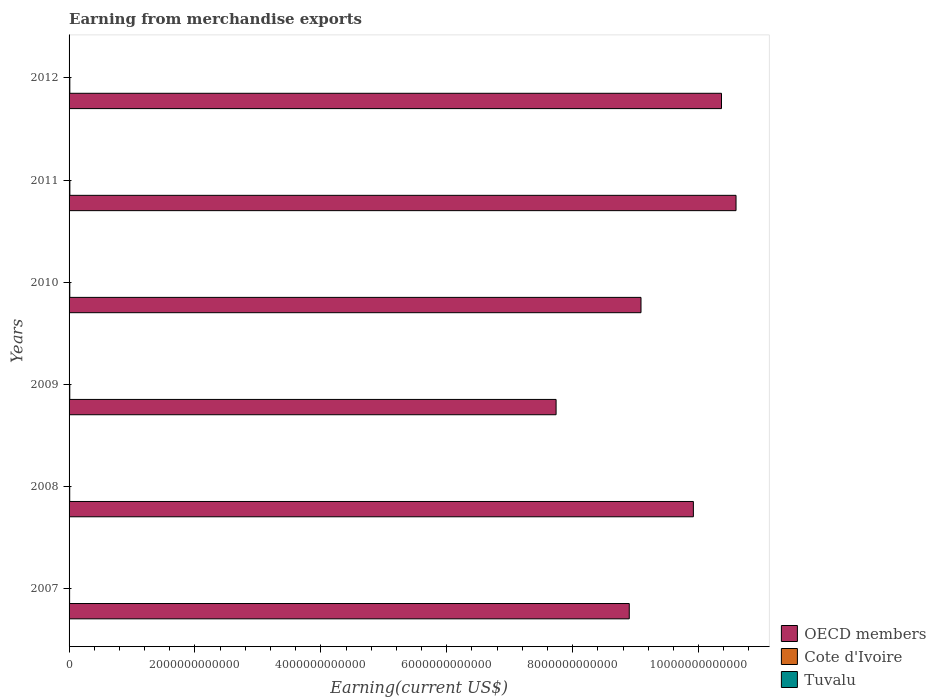Are the number of bars per tick equal to the number of legend labels?
Offer a very short reply. Yes. How many bars are there on the 5th tick from the top?
Offer a terse response. 3. What is the label of the 5th group of bars from the top?
Your answer should be very brief. 2008. In how many cases, is the number of bars for a given year not equal to the number of legend labels?
Provide a short and direct response. 0. Across all years, what is the maximum amount earned from merchandise exports in OECD members?
Keep it short and to the point. 1.06e+13. Across all years, what is the minimum amount earned from merchandise exports in Cote d'Ivoire?
Your answer should be very brief. 8.67e+09. In which year was the amount earned from merchandise exports in Cote d'Ivoire minimum?
Your answer should be compact. 2007. What is the total amount earned from merchandise exports in Tuvalu in the graph?
Ensure brevity in your answer.  1.49e+06. What is the difference between the amount earned from merchandise exports in OECD members in 2008 and that in 2009?
Provide a short and direct response. 2.18e+12. What is the difference between the amount earned from merchandise exports in Cote d'Ivoire in 2007 and the amount earned from merchandise exports in OECD members in 2012?
Offer a very short reply. -1.04e+13. What is the average amount earned from merchandise exports in OECD members per year?
Give a very brief answer. 9.43e+12. In the year 2009, what is the difference between the amount earned from merchandise exports in OECD members and amount earned from merchandise exports in Tuvalu?
Make the answer very short. 7.74e+12. In how many years, is the amount earned from merchandise exports in Tuvalu greater than 3600000000000 US$?
Ensure brevity in your answer.  0. What is the ratio of the amount earned from merchandise exports in OECD members in 2008 to that in 2009?
Your answer should be compact. 1.28. Is the amount earned from merchandise exports in Cote d'Ivoire in 2009 less than that in 2011?
Offer a terse response. Yes. Is the difference between the amount earned from merchandise exports in OECD members in 2008 and 2012 greater than the difference between the amount earned from merchandise exports in Tuvalu in 2008 and 2012?
Offer a very short reply. No. What is the difference between the highest and the second highest amount earned from merchandise exports in Cote d'Ivoire?
Your answer should be compact. 5.11e+08. What is the difference between the highest and the lowest amount earned from merchandise exports in OECD members?
Offer a very short reply. 2.86e+12. In how many years, is the amount earned from merchandise exports in Cote d'Ivoire greater than the average amount earned from merchandise exports in Cote d'Ivoire taken over all years?
Offer a very short reply. 4. Is the sum of the amount earned from merchandise exports in Cote d'Ivoire in 2008 and 2010 greater than the maximum amount earned from merchandise exports in Tuvalu across all years?
Your response must be concise. Yes. What does the 1st bar from the top in 2007 represents?
Offer a very short reply. Tuvalu. What does the 3rd bar from the bottom in 2012 represents?
Offer a very short reply. Tuvalu. How many bars are there?
Provide a succinct answer. 18. How many years are there in the graph?
Keep it short and to the point. 6. What is the difference between two consecutive major ticks on the X-axis?
Your answer should be very brief. 2.00e+12. Are the values on the major ticks of X-axis written in scientific E-notation?
Provide a succinct answer. No. Does the graph contain any zero values?
Ensure brevity in your answer.  No. Where does the legend appear in the graph?
Keep it short and to the point. Bottom right. What is the title of the graph?
Offer a terse response. Earning from merchandise exports. Does "Slovenia" appear as one of the legend labels in the graph?
Offer a very short reply. No. What is the label or title of the X-axis?
Offer a terse response. Earning(current US$). What is the Earning(current US$) of OECD members in 2007?
Your response must be concise. 8.90e+12. What is the Earning(current US$) in Cote d'Ivoire in 2007?
Your response must be concise. 8.67e+09. What is the Earning(current US$) in Tuvalu in 2007?
Your response must be concise. 9.20e+04. What is the Earning(current US$) of OECD members in 2008?
Make the answer very short. 9.92e+12. What is the Earning(current US$) of Cote d'Ivoire in 2008?
Keep it short and to the point. 1.04e+1. What is the Earning(current US$) of Tuvalu in 2008?
Ensure brevity in your answer.  2.00e+05. What is the Earning(current US$) of OECD members in 2009?
Offer a very short reply. 7.74e+12. What is the Earning(current US$) in Cote d'Ivoire in 2009?
Offer a very short reply. 1.13e+1. What is the Earning(current US$) of Tuvalu in 2009?
Provide a short and direct response. 3.00e+05. What is the Earning(current US$) in OECD members in 2010?
Offer a very short reply. 9.09e+12. What is the Earning(current US$) in Cote d'Ivoire in 2010?
Keep it short and to the point. 1.14e+1. What is the Earning(current US$) of OECD members in 2011?
Keep it short and to the point. 1.06e+13. What is the Earning(current US$) of Cote d'Ivoire in 2011?
Your answer should be very brief. 1.26e+1. What is the Earning(current US$) of Tuvalu in 2011?
Provide a short and direct response. 3.00e+05. What is the Earning(current US$) of OECD members in 2012?
Provide a short and direct response. 1.04e+13. What is the Earning(current US$) of Cote d'Ivoire in 2012?
Make the answer very short. 1.21e+1. Across all years, what is the maximum Earning(current US$) in OECD members?
Provide a short and direct response. 1.06e+13. Across all years, what is the maximum Earning(current US$) in Cote d'Ivoire?
Your answer should be compact. 1.26e+1. Across all years, what is the maximum Earning(current US$) of Tuvalu?
Your answer should be compact. 3.00e+05. Across all years, what is the minimum Earning(current US$) in OECD members?
Your answer should be very brief. 7.74e+12. Across all years, what is the minimum Earning(current US$) of Cote d'Ivoire?
Offer a terse response. 8.67e+09. Across all years, what is the minimum Earning(current US$) in Tuvalu?
Your answer should be very brief. 9.20e+04. What is the total Earning(current US$) in OECD members in the graph?
Offer a terse response. 5.66e+13. What is the total Earning(current US$) of Cote d'Ivoire in the graph?
Offer a terse response. 6.66e+1. What is the total Earning(current US$) of Tuvalu in the graph?
Your answer should be very brief. 1.49e+06. What is the difference between the Earning(current US$) of OECD members in 2007 and that in 2008?
Provide a succinct answer. -1.02e+12. What is the difference between the Earning(current US$) of Cote d'Ivoire in 2007 and that in 2008?
Provide a succinct answer. -1.72e+09. What is the difference between the Earning(current US$) in Tuvalu in 2007 and that in 2008?
Offer a very short reply. -1.08e+05. What is the difference between the Earning(current US$) in OECD members in 2007 and that in 2009?
Ensure brevity in your answer.  1.16e+12. What is the difference between the Earning(current US$) in Cote d'Ivoire in 2007 and that in 2009?
Offer a very short reply. -2.66e+09. What is the difference between the Earning(current US$) of Tuvalu in 2007 and that in 2009?
Your answer should be very brief. -2.08e+05. What is the difference between the Earning(current US$) of OECD members in 2007 and that in 2010?
Your response must be concise. -1.87e+11. What is the difference between the Earning(current US$) of Cote d'Ivoire in 2007 and that in 2010?
Ensure brevity in your answer.  -2.74e+09. What is the difference between the Earning(current US$) of Tuvalu in 2007 and that in 2010?
Offer a very short reply. -2.08e+05. What is the difference between the Earning(current US$) of OECD members in 2007 and that in 2011?
Provide a succinct answer. -1.70e+12. What is the difference between the Earning(current US$) of Cote d'Ivoire in 2007 and that in 2011?
Your answer should be compact. -3.97e+09. What is the difference between the Earning(current US$) in Tuvalu in 2007 and that in 2011?
Give a very brief answer. -2.08e+05. What is the difference between the Earning(current US$) in OECD members in 2007 and that in 2012?
Your answer should be compact. -1.47e+12. What is the difference between the Earning(current US$) in Cote d'Ivoire in 2007 and that in 2012?
Provide a succinct answer. -3.46e+09. What is the difference between the Earning(current US$) of Tuvalu in 2007 and that in 2012?
Give a very brief answer. -2.08e+05. What is the difference between the Earning(current US$) of OECD members in 2008 and that in 2009?
Your answer should be compact. 2.18e+12. What is the difference between the Earning(current US$) of Cote d'Ivoire in 2008 and that in 2009?
Your answer should be very brief. -9.37e+08. What is the difference between the Earning(current US$) of OECD members in 2008 and that in 2010?
Offer a very short reply. 8.32e+11. What is the difference between the Earning(current US$) in Cote d'Ivoire in 2008 and that in 2010?
Provide a succinct answer. -1.02e+09. What is the difference between the Earning(current US$) of OECD members in 2008 and that in 2011?
Offer a terse response. -6.78e+11. What is the difference between the Earning(current US$) of Cote d'Ivoire in 2008 and that in 2011?
Your response must be concise. -2.25e+09. What is the difference between the Earning(current US$) of Tuvalu in 2008 and that in 2011?
Offer a terse response. -1.00e+05. What is the difference between the Earning(current US$) of OECD members in 2008 and that in 2012?
Your answer should be very brief. -4.47e+11. What is the difference between the Earning(current US$) of Cote d'Ivoire in 2008 and that in 2012?
Provide a succinct answer. -1.73e+09. What is the difference between the Earning(current US$) of OECD members in 2009 and that in 2010?
Make the answer very short. -1.35e+12. What is the difference between the Earning(current US$) of Cote d'Ivoire in 2009 and that in 2010?
Keep it short and to the point. -8.33e+07. What is the difference between the Earning(current US$) of OECD members in 2009 and that in 2011?
Provide a short and direct response. -2.86e+12. What is the difference between the Earning(current US$) of Cote d'Ivoire in 2009 and that in 2011?
Offer a very short reply. -1.31e+09. What is the difference between the Earning(current US$) of OECD members in 2009 and that in 2012?
Keep it short and to the point. -2.63e+12. What is the difference between the Earning(current US$) of Cote d'Ivoire in 2009 and that in 2012?
Give a very brief answer. -7.97e+08. What is the difference between the Earning(current US$) in OECD members in 2010 and that in 2011?
Provide a short and direct response. -1.51e+12. What is the difference between the Earning(current US$) in Cote d'Ivoire in 2010 and that in 2011?
Make the answer very short. -1.22e+09. What is the difference between the Earning(current US$) in OECD members in 2010 and that in 2012?
Offer a terse response. -1.28e+12. What is the difference between the Earning(current US$) of Cote d'Ivoire in 2010 and that in 2012?
Offer a very short reply. -7.14e+08. What is the difference between the Earning(current US$) in OECD members in 2011 and that in 2012?
Ensure brevity in your answer.  2.31e+11. What is the difference between the Earning(current US$) in Cote d'Ivoire in 2011 and that in 2012?
Provide a succinct answer. 5.11e+08. What is the difference between the Earning(current US$) in Tuvalu in 2011 and that in 2012?
Give a very brief answer. 0. What is the difference between the Earning(current US$) of OECD members in 2007 and the Earning(current US$) of Cote d'Ivoire in 2008?
Provide a succinct answer. 8.89e+12. What is the difference between the Earning(current US$) in OECD members in 2007 and the Earning(current US$) in Tuvalu in 2008?
Your answer should be very brief. 8.90e+12. What is the difference between the Earning(current US$) in Cote d'Ivoire in 2007 and the Earning(current US$) in Tuvalu in 2008?
Your answer should be very brief. 8.67e+09. What is the difference between the Earning(current US$) of OECD members in 2007 and the Earning(current US$) of Cote d'Ivoire in 2009?
Provide a short and direct response. 8.89e+12. What is the difference between the Earning(current US$) in OECD members in 2007 and the Earning(current US$) in Tuvalu in 2009?
Keep it short and to the point. 8.90e+12. What is the difference between the Earning(current US$) in Cote d'Ivoire in 2007 and the Earning(current US$) in Tuvalu in 2009?
Offer a terse response. 8.67e+09. What is the difference between the Earning(current US$) of OECD members in 2007 and the Earning(current US$) of Cote d'Ivoire in 2010?
Keep it short and to the point. 8.89e+12. What is the difference between the Earning(current US$) of OECD members in 2007 and the Earning(current US$) of Tuvalu in 2010?
Your answer should be very brief. 8.90e+12. What is the difference between the Earning(current US$) of Cote d'Ivoire in 2007 and the Earning(current US$) of Tuvalu in 2010?
Provide a succinct answer. 8.67e+09. What is the difference between the Earning(current US$) in OECD members in 2007 and the Earning(current US$) in Cote d'Ivoire in 2011?
Give a very brief answer. 8.89e+12. What is the difference between the Earning(current US$) of OECD members in 2007 and the Earning(current US$) of Tuvalu in 2011?
Your answer should be very brief. 8.90e+12. What is the difference between the Earning(current US$) of Cote d'Ivoire in 2007 and the Earning(current US$) of Tuvalu in 2011?
Keep it short and to the point. 8.67e+09. What is the difference between the Earning(current US$) of OECD members in 2007 and the Earning(current US$) of Cote d'Ivoire in 2012?
Ensure brevity in your answer.  8.89e+12. What is the difference between the Earning(current US$) in OECD members in 2007 and the Earning(current US$) in Tuvalu in 2012?
Make the answer very short. 8.90e+12. What is the difference between the Earning(current US$) in Cote d'Ivoire in 2007 and the Earning(current US$) in Tuvalu in 2012?
Give a very brief answer. 8.67e+09. What is the difference between the Earning(current US$) in OECD members in 2008 and the Earning(current US$) in Cote d'Ivoire in 2009?
Your answer should be very brief. 9.91e+12. What is the difference between the Earning(current US$) in OECD members in 2008 and the Earning(current US$) in Tuvalu in 2009?
Make the answer very short. 9.92e+12. What is the difference between the Earning(current US$) of Cote d'Ivoire in 2008 and the Earning(current US$) of Tuvalu in 2009?
Your response must be concise. 1.04e+1. What is the difference between the Earning(current US$) in OECD members in 2008 and the Earning(current US$) in Cote d'Ivoire in 2010?
Provide a succinct answer. 9.91e+12. What is the difference between the Earning(current US$) in OECD members in 2008 and the Earning(current US$) in Tuvalu in 2010?
Provide a short and direct response. 9.92e+12. What is the difference between the Earning(current US$) of Cote d'Ivoire in 2008 and the Earning(current US$) of Tuvalu in 2010?
Ensure brevity in your answer.  1.04e+1. What is the difference between the Earning(current US$) in OECD members in 2008 and the Earning(current US$) in Cote d'Ivoire in 2011?
Offer a very short reply. 9.90e+12. What is the difference between the Earning(current US$) in OECD members in 2008 and the Earning(current US$) in Tuvalu in 2011?
Keep it short and to the point. 9.92e+12. What is the difference between the Earning(current US$) of Cote d'Ivoire in 2008 and the Earning(current US$) of Tuvalu in 2011?
Ensure brevity in your answer.  1.04e+1. What is the difference between the Earning(current US$) of OECD members in 2008 and the Earning(current US$) of Cote d'Ivoire in 2012?
Provide a succinct answer. 9.91e+12. What is the difference between the Earning(current US$) in OECD members in 2008 and the Earning(current US$) in Tuvalu in 2012?
Provide a succinct answer. 9.92e+12. What is the difference between the Earning(current US$) of Cote d'Ivoire in 2008 and the Earning(current US$) of Tuvalu in 2012?
Give a very brief answer. 1.04e+1. What is the difference between the Earning(current US$) in OECD members in 2009 and the Earning(current US$) in Cote d'Ivoire in 2010?
Offer a very short reply. 7.73e+12. What is the difference between the Earning(current US$) in OECD members in 2009 and the Earning(current US$) in Tuvalu in 2010?
Offer a terse response. 7.74e+12. What is the difference between the Earning(current US$) in Cote d'Ivoire in 2009 and the Earning(current US$) in Tuvalu in 2010?
Keep it short and to the point. 1.13e+1. What is the difference between the Earning(current US$) in OECD members in 2009 and the Earning(current US$) in Cote d'Ivoire in 2011?
Your answer should be very brief. 7.72e+12. What is the difference between the Earning(current US$) in OECD members in 2009 and the Earning(current US$) in Tuvalu in 2011?
Offer a terse response. 7.74e+12. What is the difference between the Earning(current US$) of Cote d'Ivoire in 2009 and the Earning(current US$) of Tuvalu in 2011?
Your answer should be very brief. 1.13e+1. What is the difference between the Earning(current US$) in OECD members in 2009 and the Earning(current US$) in Cote d'Ivoire in 2012?
Offer a very short reply. 7.72e+12. What is the difference between the Earning(current US$) in OECD members in 2009 and the Earning(current US$) in Tuvalu in 2012?
Your answer should be very brief. 7.74e+12. What is the difference between the Earning(current US$) of Cote d'Ivoire in 2009 and the Earning(current US$) of Tuvalu in 2012?
Make the answer very short. 1.13e+1. What is the difference between the Earning(current US$) in OECD members in 2010 and the Earning(current US$) in Cote d'Ivoire in 2011?
Your response must be concise. 9.07e+12. What is the difference between the Earning(current US$) in OECD members in 2010 and the Earning(current US$) in Tuvalu in 2011?
Ensure brevity in your answer.  9.09e+12. What is the difference between the Earning(current US$) in Cote d'Ivoire in 2010 and the Earning(current US$) in Tuvalu in 2011?
Offer a terse response. 1.14e+1. What is the difference between the Earning(current US$) of OECD members in 2010 and the Earning(current US$) of Cote d'Ivoire in 2012?
Provide a succinct answer. 9.07e+12. What is the difference between the Earning(current US$) of OECD members in 2010 and the Earning(current US$) of Tuvalu in 2012?
Your response must be concise. 9.09e+12. What is the difference between the Earning(current US$) of Cote d'Ivoire in 2010 and the Earning(current US$) of Tuvalu in 2012?
Your answer should be very brief. 1.14e+1. What is the difference between the Earning(current US$) of OECD members in 2011 and the Earning(current US$) of Cote d'Ivoire in 2012?
Your response must be concise. 1.06e+13. What is the difference between the Earning(current US$) in OECD members in 2011 and the Earning(current US$) in Tuvalu in 2012?
Give a very brief answer. 1.06e+13. What is the difference between the Earning(current US$) in Cote d'Ivoire in 2011 and the Earning(current US$) in Tuvalu in 2012?
Your response must be concise. 1.26e+1. What is the average Earning(current US$) of OECD members per year?
Ensure brevity in your answer.  9.43e+12. What is the average Earning(current US$) of Cote d'Ivoire per year?
Offer a very short reply. 1.11e+1. What is the average Earning(current US$) in Tuvalu per year?
Keep it short and to the point. 2.49e+05. In the year 2007, what is the difference between the Earning(current US$) of OECD members and Earning(current US$) of Cote d'Ivoire?
Make the answer very short. 8.89e+12. In the year 2007, what is the difference between the Earning(current US$) of OECD members and Earning(current US$) of Tuvalu?
Make the answer very short. 8.90e+12. In the year 2007, what is the difference between the Earning(current US$) in Cote d'Ivoire and Earning(current US$) in Tuvalu?
Ensure brevity in your answer.  8.67e+09. In the year 2008, what is the difference between the Earning(current US$) in OECD members and Earning(current US$) in Cote d'Ivoire?
Your answer should be compact. 9.91e+12. In the year 2008, what is the difference between the Earning(current US$) in OECD members and Earning(current US$) in Tuvalu?
Make the answer very short. 9.92e+12. In the year 2008, what is the difference between the Earning(current US$) of Cote d'Ivoire and Earning(current US$) of Tuvalu?
Your answer should be very brief. 1.04e+1. In the year 2009, what is the difference between the Earning(current US$) in OECD members and Earning(current US$) in Cote d'Ivoire?
Provide a succinct answer. 7.73e+12. In the year 2009, what is the difference between the Earning(current US$) in OECD members and Earning(current US$) in Tuvalu?
Provide a short and direct response. 7.74e+12. In the year 2009, what is the difference between the Earning(current US$) in Cote d'Ivoire and Earning(current US$) in Tuvalu?
Provide a succinct answer. 1.13e+1. In the year 2010, what is the difference between the Earning(current US$) of OECD members and Earning(current US$) of Cote d'Ivoire?
Make the answer very short. 9.07e+12. In the year 2010, what is the difference between the Earning(current US$) in OECD members and Earning(current US$) in Tuvalu?
Give a very brief answer. 9.09e+12. In the year 2010, what is the difference between the Earning(current US$) of Cote d'Ivoire and Earning(current US$) of Tuvalu?
Provide a succinct answer. 1.14e+1. In the year 2011, what is the difference between the Earning(current US$) in OECD members and Earning(current US$) in Cote d'Ivoire?
Make the answer very short. 1.06e+13. In the year 2011, what is the difference between the Earning(current US$) of OECD members and Earning(current US$) of Tuvalu?
Keep it short and to the point. 1.06e+13. In the year 2011, what is the difference between the Earning(current US$) in Cote d'Ivoire and Earning(current US$) in Tuvalu?
Give a very brief answer. 1.26e+1. In the year 2012, what is the difference between the Earning(current US$) in OECD members and Earning(current US$) in Cote d'Ivoire?
Offer a very short reply. 1.04e+13. In the year 2012, what is the difference between the Earning(current US$) in OECD members and Earning(current US$) in Tuvalu?
Provide a succinct answer. 1.04e+13. In the year 2012, what is the difference between the Earning(current US$) in Cote d'Ivoire and Earning(current US$) in Tuvalu?
Offer a very short reply. 1.21e+1. What is the ratio of the Earning(current US$) in OECD members in 2007 to that in 2008?
Make the answer very short. 0.9. What is the ratio of the Earning(current US$) in Cote d'Ivoire in 2007 to that in 2008?
Ensure brevity in your answer.  0.83. What is the ratio of the Earning(current US$) in Tuvalu in 2007 to that in 2008?
Your answer should be compact. 0.46. What is the ratio of the Earning(current US$) in OECD members in 2007 to that in 2009?
Your answer should be compact. 1.15. What is the ratio of the Earning(current US$) in Cote d'Ivoire in 2007 to that in 2009?
Make the answer very short. 0.77. What is the ratio of the Earning(current US$) of Tuvalu in 2007 to that in 2009?
Your response must be concise. 0.31. What is the ratio of the Earning(current US$) in OECD members in 2007 to that in 2010?
Make the answer very short. 0.98. What is the ratio of the Earning(current US$) in Cote d'Ivoire in 2007 to that in 2010?
Ensure brevity in your answer.  0.76. What is the ratio of the Earning(current US$) of Tuvalu in 2007 to that in 2010?
Provide a short and direct response. 0.31. What is the ratio of the Earning(current US$) of OECD members in 2007 to that in 2011?
Make the answer very short. 0.84. What is the ratio of the Earning(current US$) of Cote d'Ivoire in 2007 to that in 2011?
Make the answer very short. 0.69. What is the ratio of the Earning(current US$) in Tuvalu in 2007 to that in 2011?
Give a very brief answer. 0.31. What is the ratio of the Earning(current US$) of OECD members in 2007 to that in 2012?
Offer a terse response. 0.86. What is the ratio of the Earning(current US$) in Cote d'Ivoire in 2007 to that in 2012?
Offer a very short reply. 0.71. What is the ratio of the Earning(current US$) of Tuvalu in 2007 to that in 2012?
Provide a succinct answer. 0.31. What is the ratio of the Earning(current US$) in OECD members in 2008 to that in 2009?
Your answer should be very brief. 1.28. What is the ratio of the Earning(current US$) of Cote d'Ivoire in 2008 to that in 2009?
Provide a succinct answer. 0.92. What is the ratio of the Earning(current US$) of OECD members in 2008 to that in 2010?
Make the answer very short. 1.09. What is the ratio of the Earning(current US$) in Cote d'Ivoire in 2008 to that in 2010?
Your answer should be very brief. 0.91. What is the ratio of the Earning(current US$) in Tuvalu in 2008 to that in 2010?
Give a very brief answer. 0.67. What is the ratio of the Earning(current US$) in OECD members in 2008 to that in 2011?
Your answer should be compact. 0.94. What is the ratio of the Earning(current US$) of Cote d'Ivoire in 2008 to that in 2011?
Keep it short and to the point. 0.82. What is the ratio of the Earning(current US$) in OECD members in 2008 to that in 2012?
Offer a very short reply. 0.96. What is the ratio of the Earning(current US$) of Cote d'Ivoire in 2008 to that in 2012?
Provide a succinct answer. 0.86. What is the ratio of the Earning(current US$) of OECD members in 2009 to that in 2010?
Your response must be concise. 0.85. What is the ratio of the Earning(current US$) in Tuvalu in 2009 to that in 2010?
Provide a succinct answer. 1. What is the ratio of the Earning(current US$) of OECD members in 2009 to that in 2011?
Provide a succinct answer. 0.73. What is the ratio of the Earning(current US$) of Cote d'Ivoire in 2009 to that in 2011?
Your answer should be compact. 0.9. What is the ratio of the Earning(current US$) in OECD members in 2009 to that in 2012?
Keep it short and to the point. 0.75. What is the ratio of the Earning(current US$) of Cote d'Ivoire in 2009 to that in 2012?
Give a very brief answer. 0.93. What is the ratio of the Earning(current US$) of Tuvalu in 2009 to that in 2012?
Offer a terse response. 1. What is the ratio of the Earning(current US$) of OECD members in 2010 to that in 2011?
Your answer should be very brief. 0.86. What is the ratio of the Earning(current US$) in Cote d'Ivoire in 2010 to that in 2011?
Provide a succinct answer. 0.9. What is the ratio of the Earning(current US$) in Tuvalu in 2010 to that in 2011?
Give a very brief answer. 1. What is the ratio of the Earning(current US$) in OECD members in 2010 to that in 2012?
Keep it short and to the point. 0.88. What is the ratio of the Earning(current US$) in Cote d'Ivoire in 2010 to that in 2012?
Make the answer very short. 0.94. What is the ratio of the Earning(current US$) of Tuvalu in 2010 to that in 2012?
Give a very brief answer. 1. What is the ratio of the Earning(current US$) of OECD members in 2011 to that in 2012?
Your answer should be very brief. 1.02. What is the ratio of the Earning(current US$) of Cote d'Ivoire in 2011 to that in 2012?
Ensure brevity in your answer.  1.04. What is the difference between the highest and the second highest Earning(current US$) of OECD members?
Provide a succinct answer. 2.31e+11. What is the difference between the highest and the second highest Earning(current US$) in Cote d'Ivoire?
Make the answer very short. 5.11e+08. What is the difference between the highest and the lowest Earning(current US$) in OECD members?
Ensure brevity in your answer.  2.86e+12. What is the difference between the highest and the lowest Earning(current US$) of Cote d'Ivoire?
Your answer should be compact. 3.97e+09. What is the difference between the highest and the lowest Earning(current US$) in Tuvalu?
Make the answer very short. 2.08e+05. 